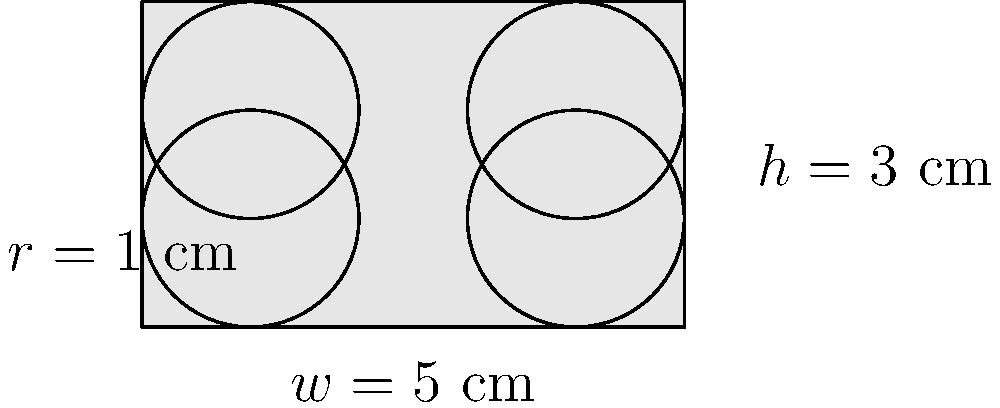A new wearable device has a display screen with rounded corners, as shown in the diagram. The screen has a width of 5 cm, a height of 3 cm, and corner radii of 1 cm. Calculate the perimeter of the display screen to determine the length of the protective bezel required. Round your answer to two decimal places. To calculate the perimeter of the display screen with rounded corners, we need to:

1. Calculate the length of straight edges:
   - Horizontal straight edges: $w - 2r = 5 - 2(1) = 3$ cm (top and bottom)
   - Vertical straight edges: $h - 2r = 3 - 2(1) = 1$ cm (left and right)
   Total straight edge length: $2(3) + 2(1) = 8$ cm

2. Calculate the length of curved edges:
   - Each corner is a quarter circle with radius 1 cm
   - Circumference of a full circle: $2\pi r = 2\pi(1) = 2\pi$ cm
   - Length of one quarter circle: $\frac{2\pi}{4} = \frac{\pi}{2}$ cm
   - There are 4 corners, so total curved length: $4 \cdot \frac{\pi}{2} = 2\pi$ cm

3. Sum up the total perimeter:
   Total perimeter = Straight edge length + Curved edge length
   $= 8 + 2\pi$ cm
   $= 8 + 2(3.14159...)$ cm
   $\approx 14.28$ cm (rounded to two decimal places)
Answer: 14.28 cm 